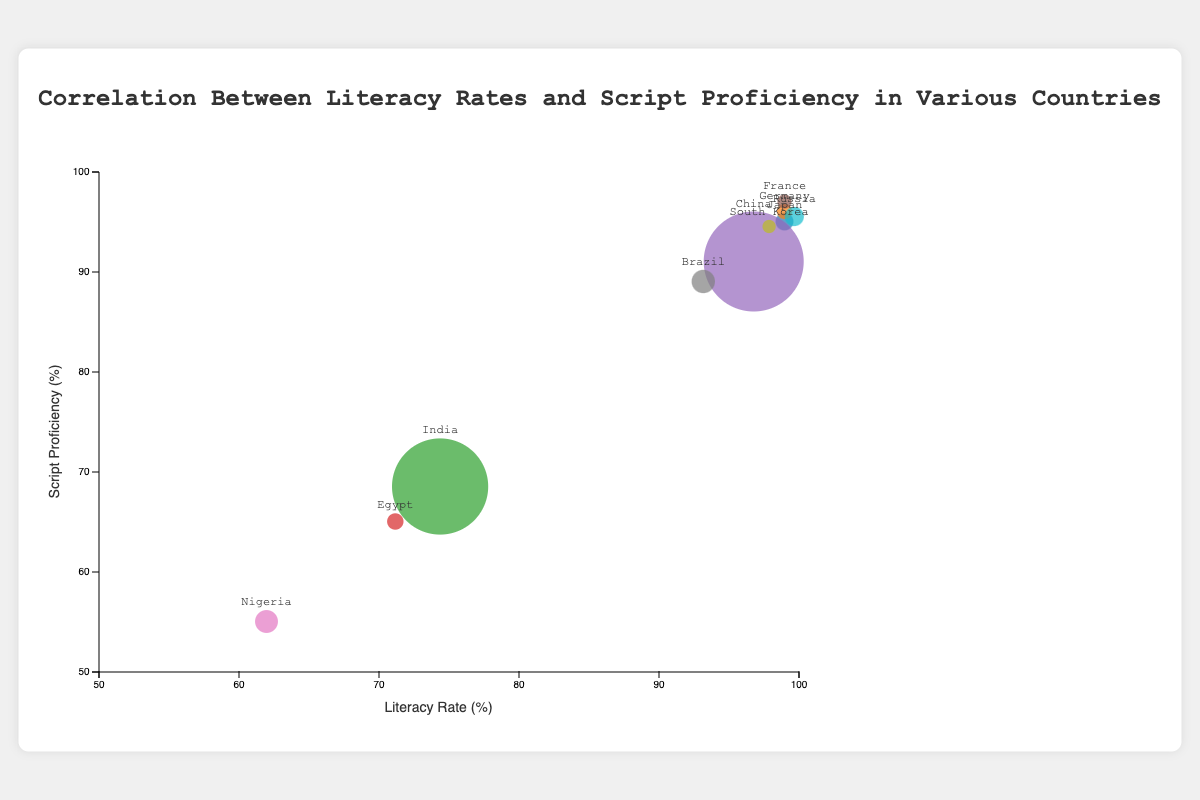What is the title of the bubble chart? The title is the text at the top of the chart, which describes the main idea of the visualization.
Answer: Correlation Between Literacy Rates and Script Proficiency in Various Countries What does the x-axis represent? The x-axis of the chart is the horizontal line labeled with its representative category. According to the placement and label, it represents Literacy Rate (%).
Answer: Literacy Rate (%) Which country has the highest script proficiency? To find the country with the highest script proficiency, locate the bubble positioned highest on the y-axis.
Answer: France How many countries have a literacy rate of 99%? To determine this, count the bubbles that align with the 99% mark on the x-axis.
Answer: 4 Which country has the lowest script proficiency, and what is its literacy rate? Locate the bubble positioned lowest on the y-axis and check its corresponding x-axis value.
Answer: Nigeria, 62% Estimate the median literacy rate of the countries represented. List the literacy rates in order (62, 71.2, 74.4, 93.2, 96.8, 97.9, 99, 99, 99, 99.7) and find the middle value. For an even number of observations, the median is the average of the two middle values.
Answer: 97.9% How does the script proficiency of China compare with that of India? Locate the bubbles for China and India, compare their y-axis positions to see which is higher.
Answer: China has higher script proficiency than India Which country has the largest bubble, and what does this represent? Identify the largest bubble and refer to its size representing population.
Answer: China, representing a population of 1441 million Identify any clusters of countries with both high literacy rates and high script proficiency. Look for groups of bubbles located in the upper right portion of the chart. Countries close together with literacy rates and script proficiency rates above 90% form clusters.
Answer: Japan, Germany, France, South Korea, Russia What is the difference in literacy rate between the country with the highest literacy rate and the country with the lowest literacy rate? Determine the highest literacy rate and the lowest literacy rate from the chart and calculate their difference.
Answer: 99.7% - 62% = 37.7% 